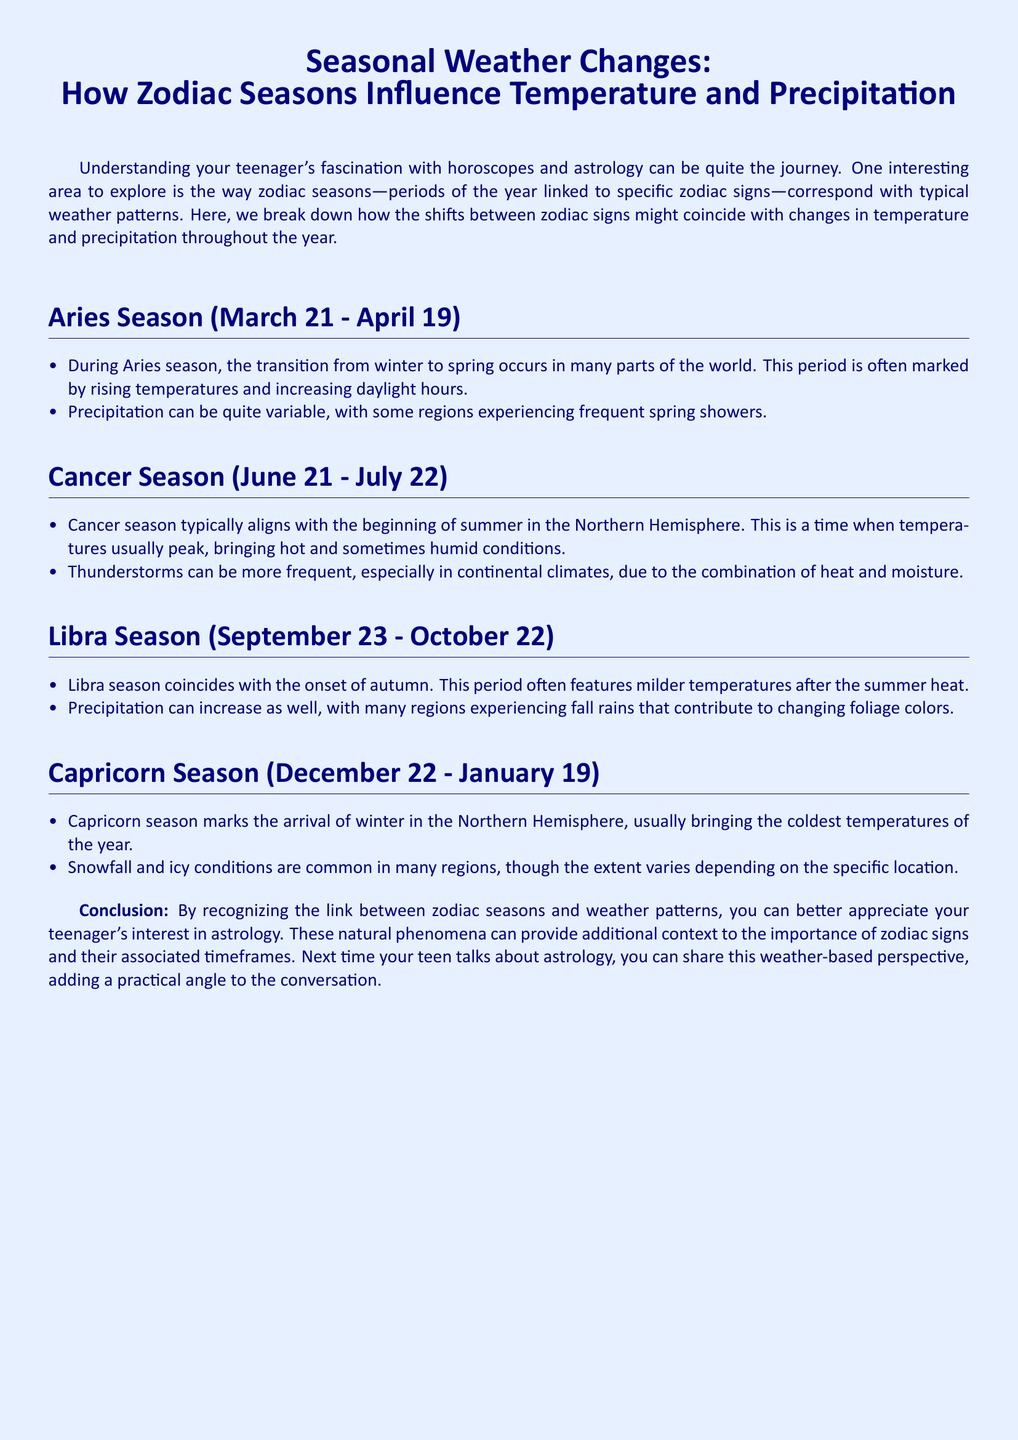What dates do Aries season span? Aries season lasts from March 21 to April 19.
Answer: March 21 - April 19 What typically occurs during Cancer season? Cancer season usually aligns with the beginning of summer, bringing hot and humid conditions.
Answer: Beginning of summer What type of precipitation is common in Libra season? During Libra season, many regions experience fall rains that contribute to changing foliage colors.
Answer: Fall rains What weather condition is common during Capricorn season? Capricorn season usually brings the coldest temperatures of the year along with snowfall and icy conditions.
Answer: Snowfall What can you find during Aries season? Aries season can be marked by rising temperatures and increasing daylight hours.
Answer: Rising temperatures How long does Libra season last? Libra season spans from September 23 to October 22.
Answer: September 23 - October 22 What happens to temperatures during Cancer season? Temperatures usually peak, bringing hot and sometimes humid conditions during Cancer season.
Answer: Temperatures peak What effect does Capricorn season have on regions? In Capricorn season, many regions experience cold temperatures and snowfall, varying by location.
Answer: Cold temperatures and snowfall What natural phenomena align with the zodiac signs? The document relates zodiac seasons to shifts in temperature and precipitation.
Answer: Shifts in temperature and precipitation 